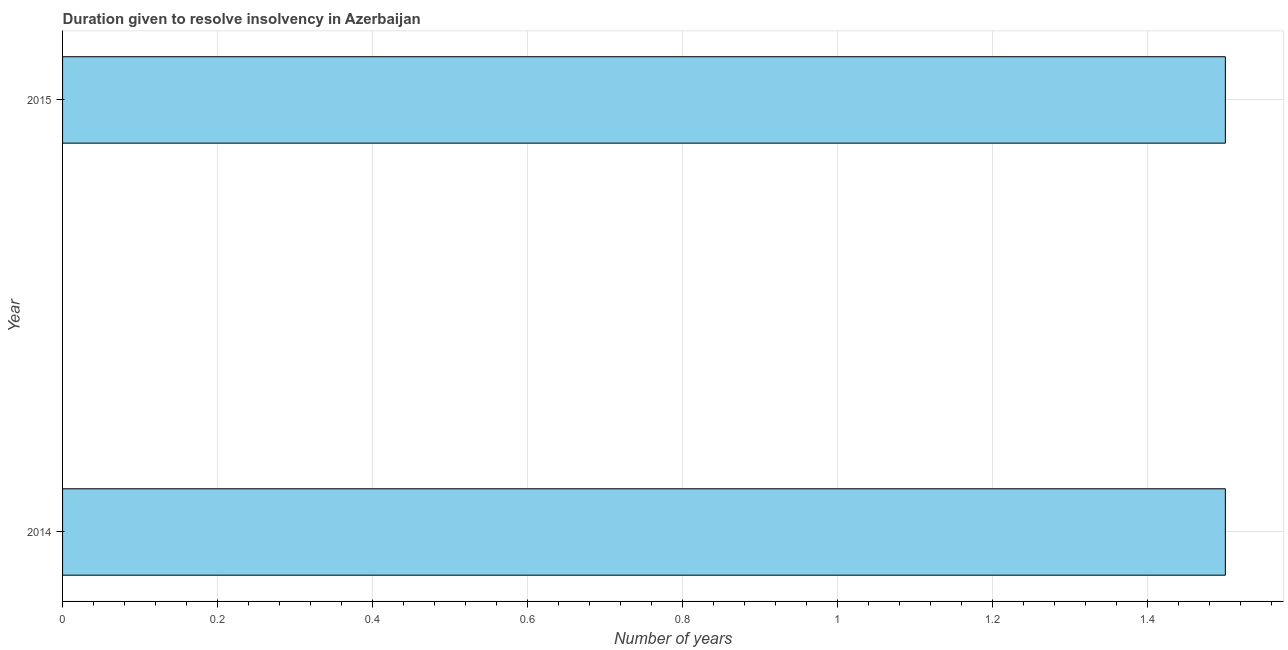Does the graph contain grids?
Ensure brevity in your answer.  Yes. What is the title of the graph?
Your response must be concise. Duration given to resolve insolvency in Azerbaijan. What is the label or title of the X-axis?
Offer a terse response. Number of years. What is the label or title of the Y-axis?
Provide a succinct answer. Year. What is the number of years to resolve insolvency in 2014?
Offer a terse response. 1.5. Across all years, what is the maximum number of years to resolve insolvency?
Provide a short and direct response. 1.5. In which year was the number of years to resolve insolvency maximum?
Offer a very short reply. 2014. What is the sum of the number of years to resolve insolvency?
Your response must be concise. 3. What is the difference between the number of years to resolve insolvency in 2014 and 2015?
Provide a short and direct response. 0. What is the average number of years to resolve insolvency per year?
Offer a terse response. 1.5. In how many years, is the number of years to resolve insolvency greater than 0.76 ?
Keep it short and to the point. 2. What is the ratio of the number of years to resolve insolvency in 2014 to that in 2015?
Your response must be concise. 1. Are all the bars in the graph horizontal?
Offer a very short reply. Yes. How many years are there in the graph?
Your answer should be very brief. 2. Are the values on the major ticks of X-axis written in scientific E-notation?
Your answer should be compact. No. What is the difference between the Number of years in 2014 and 2015?
Provide a succinct answer. 0. 